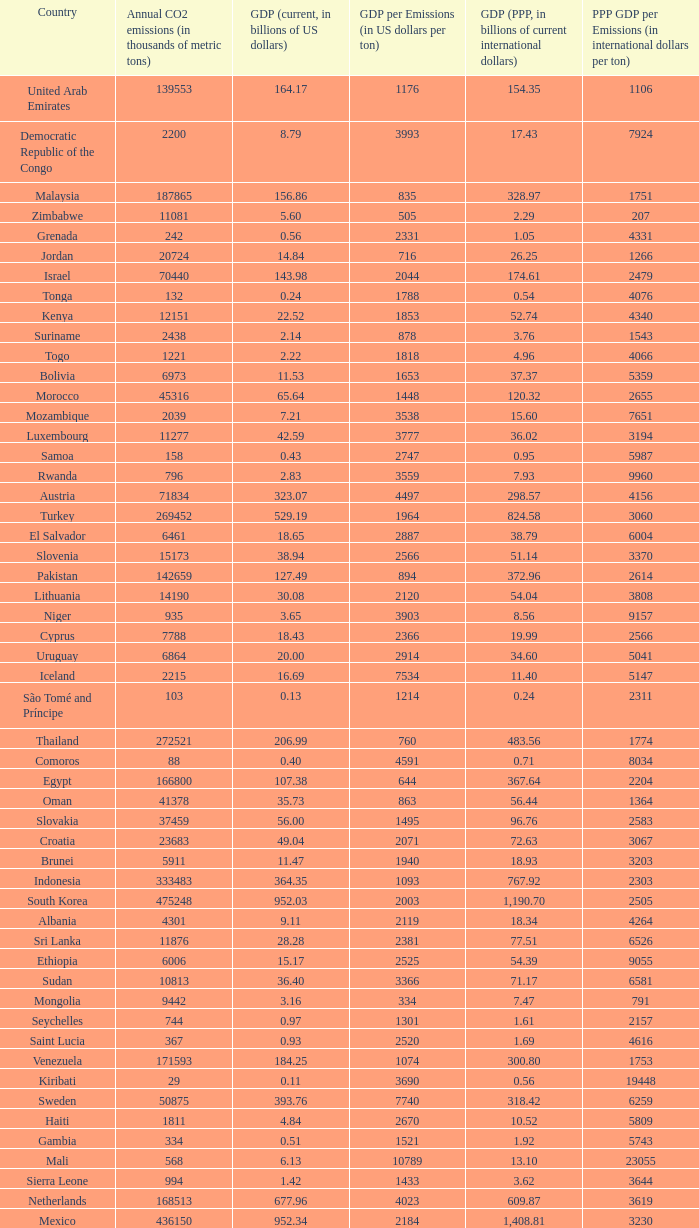When the gdp per emissions (in us dollars per ton) is 3903, what is the maximum annual co2 emissions (in thousands of metric tons)? 935.0. 